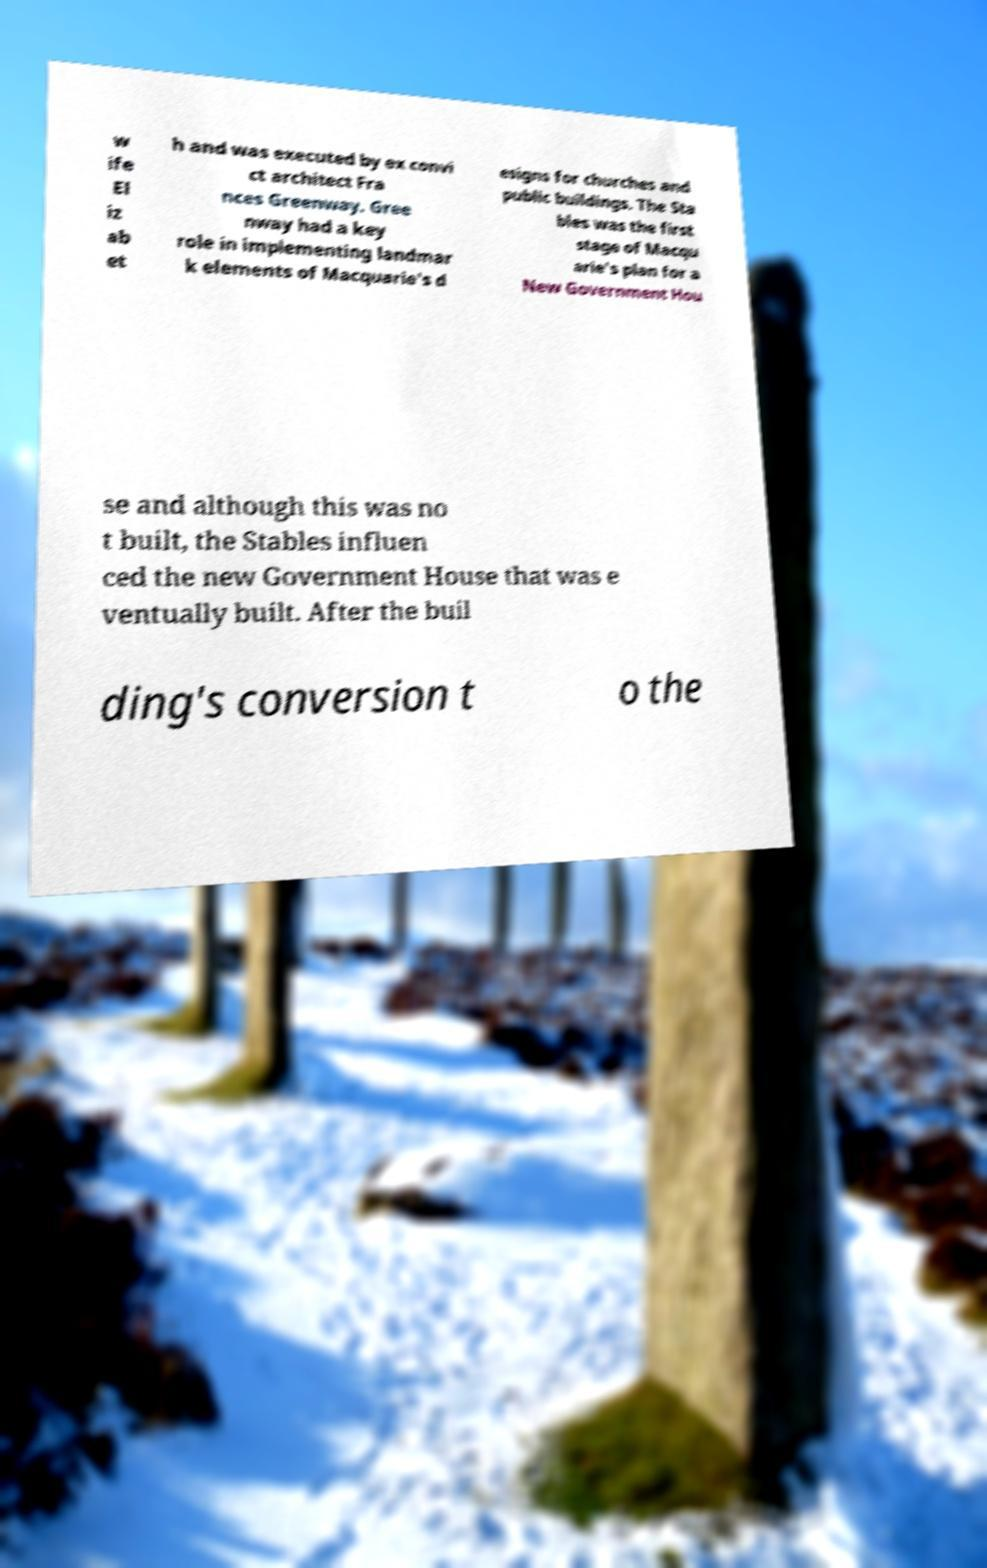Please identify and transcribe the text found in this image. w ife El iz ab et h and was executed by ex convi ct architect Fra nces Greenway. Gree nway had a key role in implementing landmar k elements of Macquarie's d esigns for churches and public buildings. The Sta bles was the first stage of Macqu arie's plan for a New Government Hou se and although this was no t built, the Stables influen ced the new Government House that was e ventually built. After the buil ding's conversion t o the 